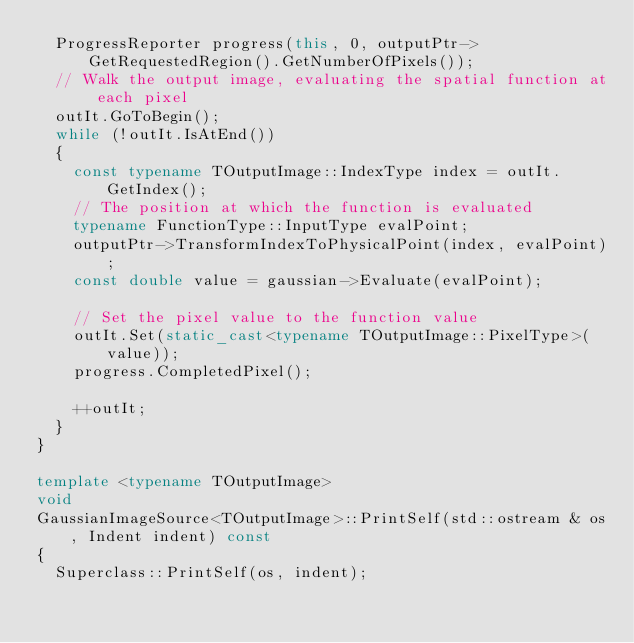Convert code to text. <code><loc_0><loc_0><loc_500><loc_500><_C++_>  ProgressReporter progress(this, 0, outputPtr->GetRequestedRegion().GetNumberOfPixels());
  // Walk the output image, evaluating the spatial function at each pixel
  outIt.GoToBegin();
  while (!outIt.IsAtEnd())
  {
    const typename TOutputImage::IndexType index = outIt.GetIndex();
    // The position at which the function is evaluated
    typename FunctionType::InputType evalPoint;
    outputPtr->TransformIndexToPhysicalPoint(index, evalPoint);
    const double value = gaussian->Evaluate(evalPoint);

    // Set the pixel value to the function value
    outIt.Set(static_cast<typename TOutputImage::PixelType>(value));
    progress.CompletedPixel();

    ++outIt;
  }
}

template <typename TOutputImage>
void
GaussianImageSource<TOutputImage>::PrintSelf(std::ostream & os, Indent indent) const
{
  Superclass::PrintSelf(os, indent);
</code> 